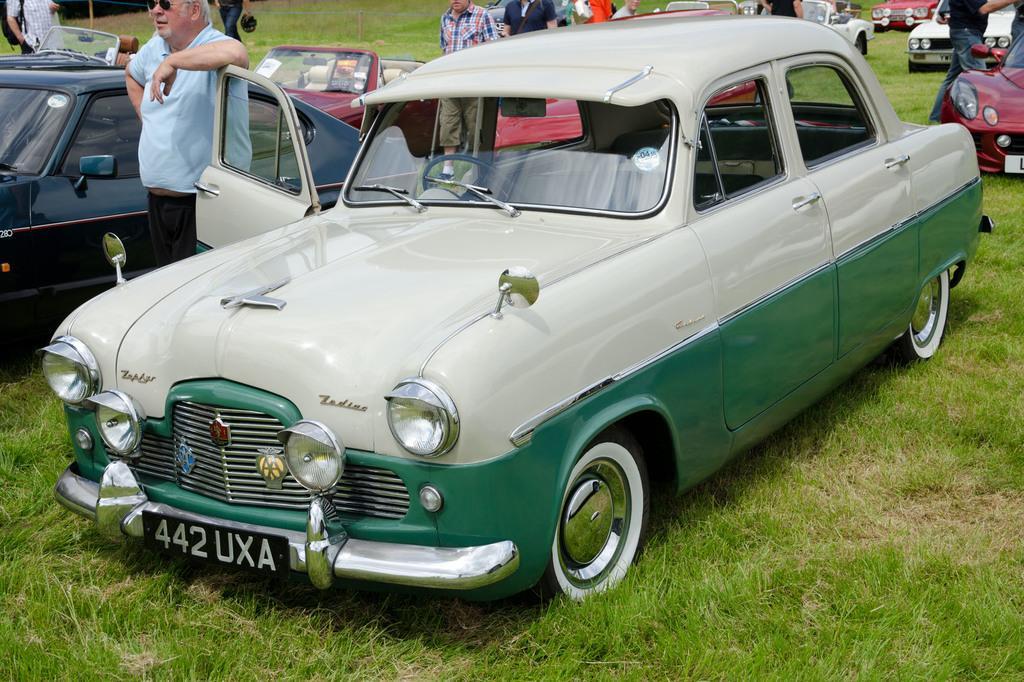Describe this image in one or two sentences. In this image we can see the cars. And we can see the surrounding people. And we can see the grass. 